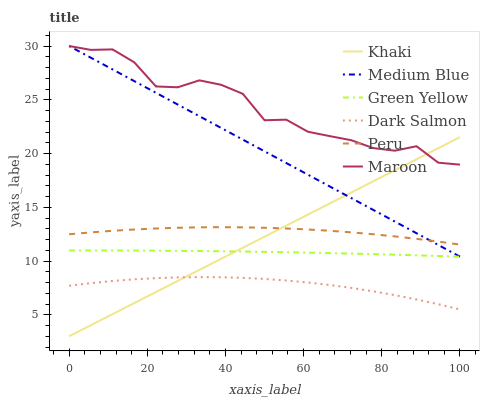Does Dark Salmon have the minimum area under the curve?
Answer yes or no. Yes. Does Maroon have the maximum area under the curve?
Answer yes or no. Yes. Does Medium Blue have the minimum area under the curve?
Answer yes or no. No. Does Medium Blue have the maximum area under the curve?
Answer yes or no. No. Is Khaki the smoothest?
Answer yes or no. Yes. Is Maroon the roughest?
Answer yes or no. Yes. Is Medium Blue the smoothest?
Answer yes or no. No. Is Medium Blue the roughest?
Answer yes or no. No. Does Khaki have the lowest value?
Answer yes or no. Yes. Does Medium Blue have the lowest value?
Answer yes or no. No. Does Maroon have the highest value?
Answer yes or no. Yes. Does Dark Salmon have the highest value?
Answer yes or no. No. Is Green Yellow less than Peru?
Answer yes or no. Yes. Is Maroon greater than Green Yellow?
Answer yes or no. Yes. Does Maroon intersect Khaki?
Answer yes or no. Yes. Is Maroon less than Khaki?
Answer yes or no. No. Is Maroon greater than Khaki?
Answer yes or no. No. Does Green Yellow intersect Peru?
Answer yes or no. No. 